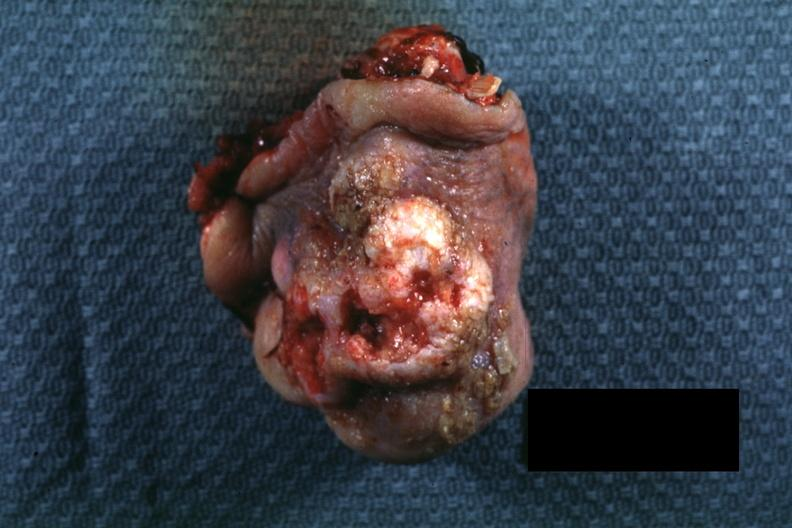what is present?
Answer the question using a single word or phrase. Squamous cell carcinoma 